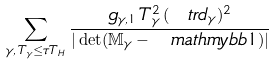<formula> <loc_0><loc_0><loc_500><loc_500>\sum _ { \gamma , \, T _ { \gamma } \leq \tau T _ { H } } \frac { g _ { \gamma , 1 } \, T _ { \gamma } ^ { 2 } \, ( \ t r d _ { \gamma } ) ^ { 2 } } { | \det ( \mathbb { M } _ { \gamma } - \ m a t h m y b b { 1 } ) | }</formula> 